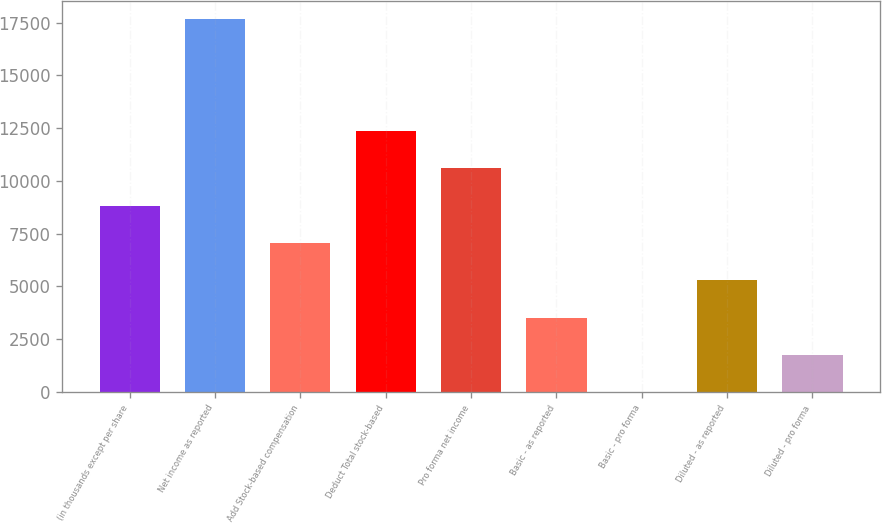Convert chart. <chart><loc_0><loc_0><loc_500><loc_500><bar_chart><fcel>(in thousands except per share<fcel>Net income as reported<fcel>Add Stock-based compensation<fcel>Deduct Total stock-based<fcel>Pro forma net income<fcel>Basic - as reported<fcel>Basic - pro forma<fcel>Diluted - as reported<fcel>Diluted - pro forma<nl><fcel>8826.09<fcel>17652<fcel>7060.9<fcel>12356.5<fcel>10591.3<fcel>3530.52<fcel>0.14<fcel>5295.71<fcel>1765.33<nl></chart> 